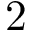Convert formula to latex. <formula><loc_0><loc_0><loc_500><loc_500>2</formula> 